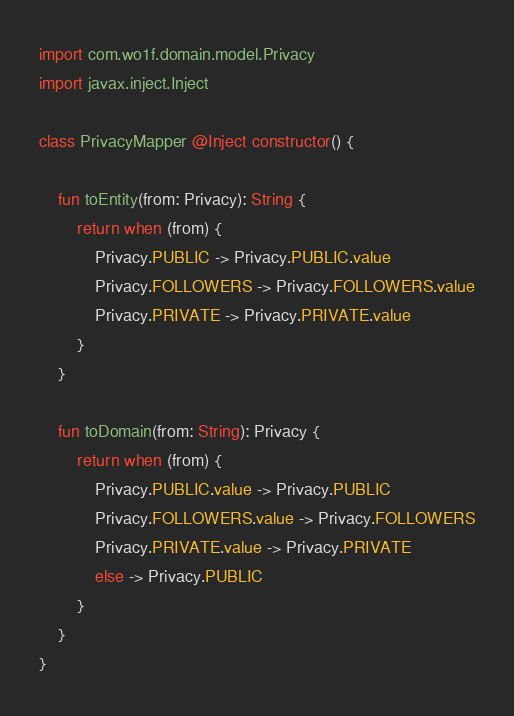Convert code to text. <code><loc_0><loc_0><loc_500><loc_500><_Kotlin_>import com.wo1f.domain.model.Privacy
import javax.inject.Inject

class PrivacyMapper @Inject constructor() {

    fun toEntity(from: Privacy): String {
        return when (from) {
            Privacy.PUBLIC -> Privacy.PUBLIC.value
            Privacy.FOLLOWERS -> Privacy.FOLLOWERS.value
            Privacy.PRIVATE -> Privacy.PRIVATE.value
        }
    }

    fun toDomain(from: String): Privacy {
        return when (from) {
            Privacy.PUBLIC.value -> Privacy.PUBLIC
            Privacy.FOLLOWERS.value -> Privacy.FOLLOWERS
            Privacy.PRIVATE.value -> Privacy.PRIVATE
            else -> Privacy.PUBLIC
        }
    }
}
</code> 